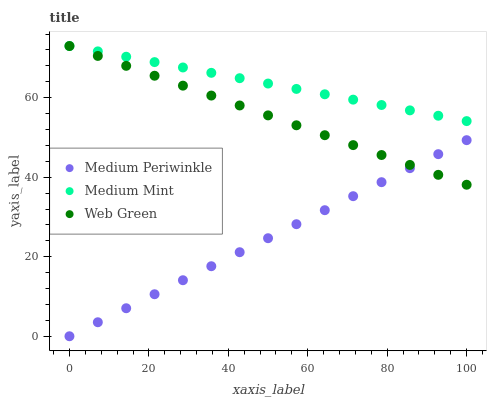Does Medium Periwinkle have the minimum area under the curve?
Answer yes or no. Yes. Does Medium Mint have the maximum area under the curve?
Answer yes or no. Yes. Does Web Green have the minimum area under the curve?
Answer yes or no. No. Does Web Green have the maximum area under the curve?
Answer yes or no. No. Is Medium Periwinkle the smoothest?
Answer yes or no. Yes. Is Web Green the roughest?
Answer yes or no. Yes. Is Web Green the smoothest?
Answer yes or no. No. Is Medium Periwinkle the roughest?
Answer yes or no. No. Does Medium Periwinkle have the lowest value?
Answer yes or no. Yes. Does Web Green have the lowest value?
Answer yes or no. No. Does Web Green have the highest value?
Answer yes or no. Yes. Does Medium Periwinkle have the highest value?
Answer yes or no. No. Is Medium Periwinkle less than Medium Mint?
Answer yes or no. Yes. Is Medium Mint greater than Medium Periwinkle?
Answer yes or no. Yes. Does Medium Mint intersect Web Green?
Answer yes or no. Yes. Is Medium Mint less than Web Green?
Answer yes or no. No. Is Medium Mint greater than Web Green?
Answer yes or no. No. Does Medium Periwinkle intersect Medium Mint?
Answer yes or no. No. 